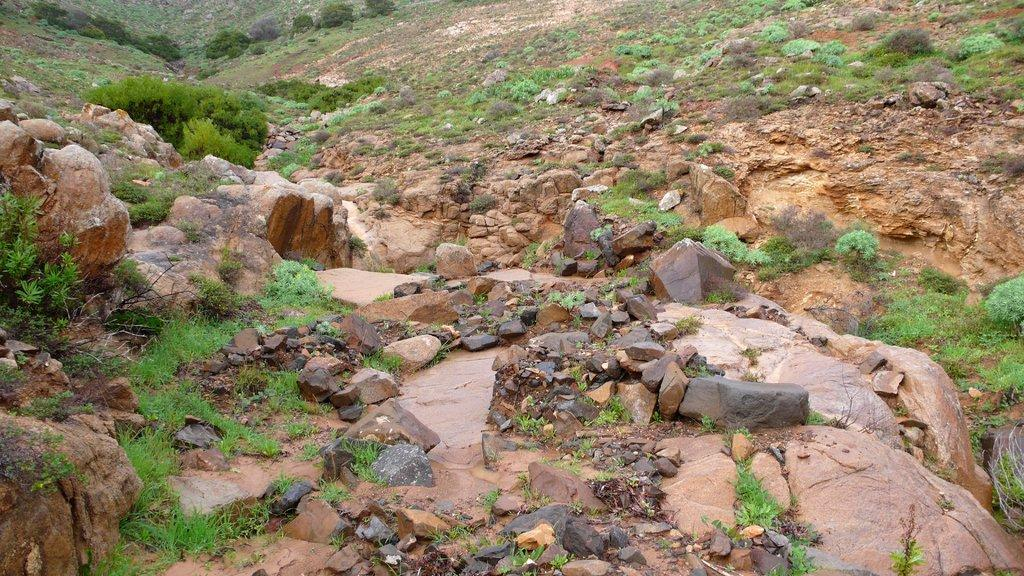What type of ground surface is visible in the image? There are stones and grass on the ground in the image. Can you describe the texture of the ground surface? The stones and grass on the ground provide a varied texture in the image. Is there a crown visible on the grass in the image? No, there is no crown present in the image. Can you describe the insects that are crawling on the stones in the image? There are no insects mentioned or visible in the image. 